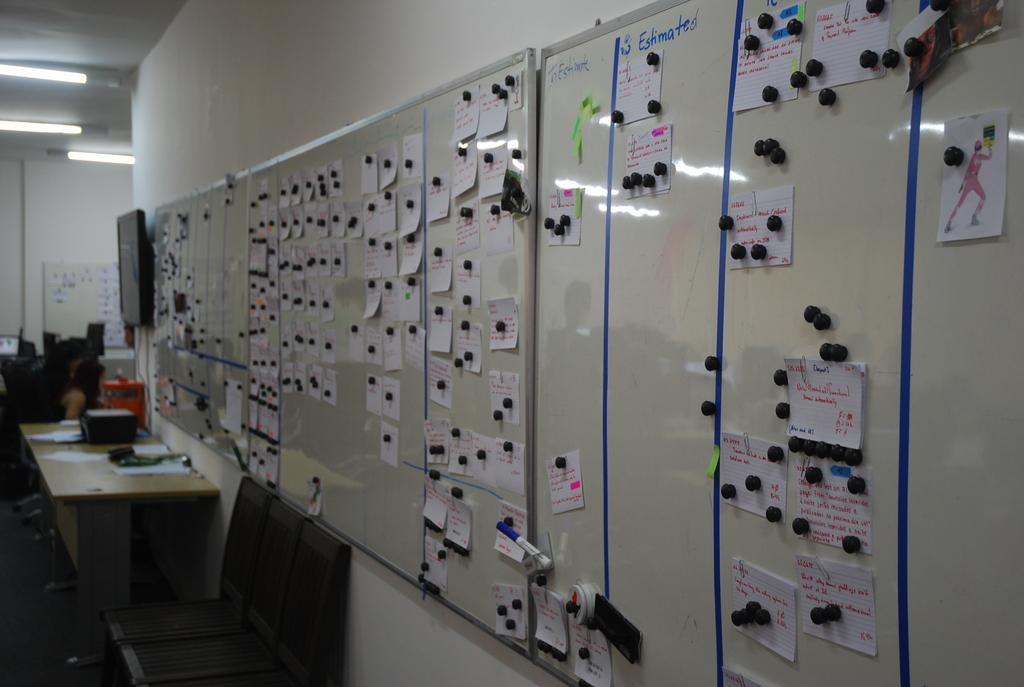What is on the board in the image? There are sticky notes on the board. What electronic device is present in the image? There is a television in the image. What is on the table in the image? There is paper on the table. What type of furniture is in the image? There are chairs in the image. What is a large, flat surface in the image? There is a wall in the image. What type of plants can be seen growing on the television in the image? There are no plants growing on the television in the image. How does the fear of the unknown affect the people in the image? There is no indication of fear or any emotional state in the image. 